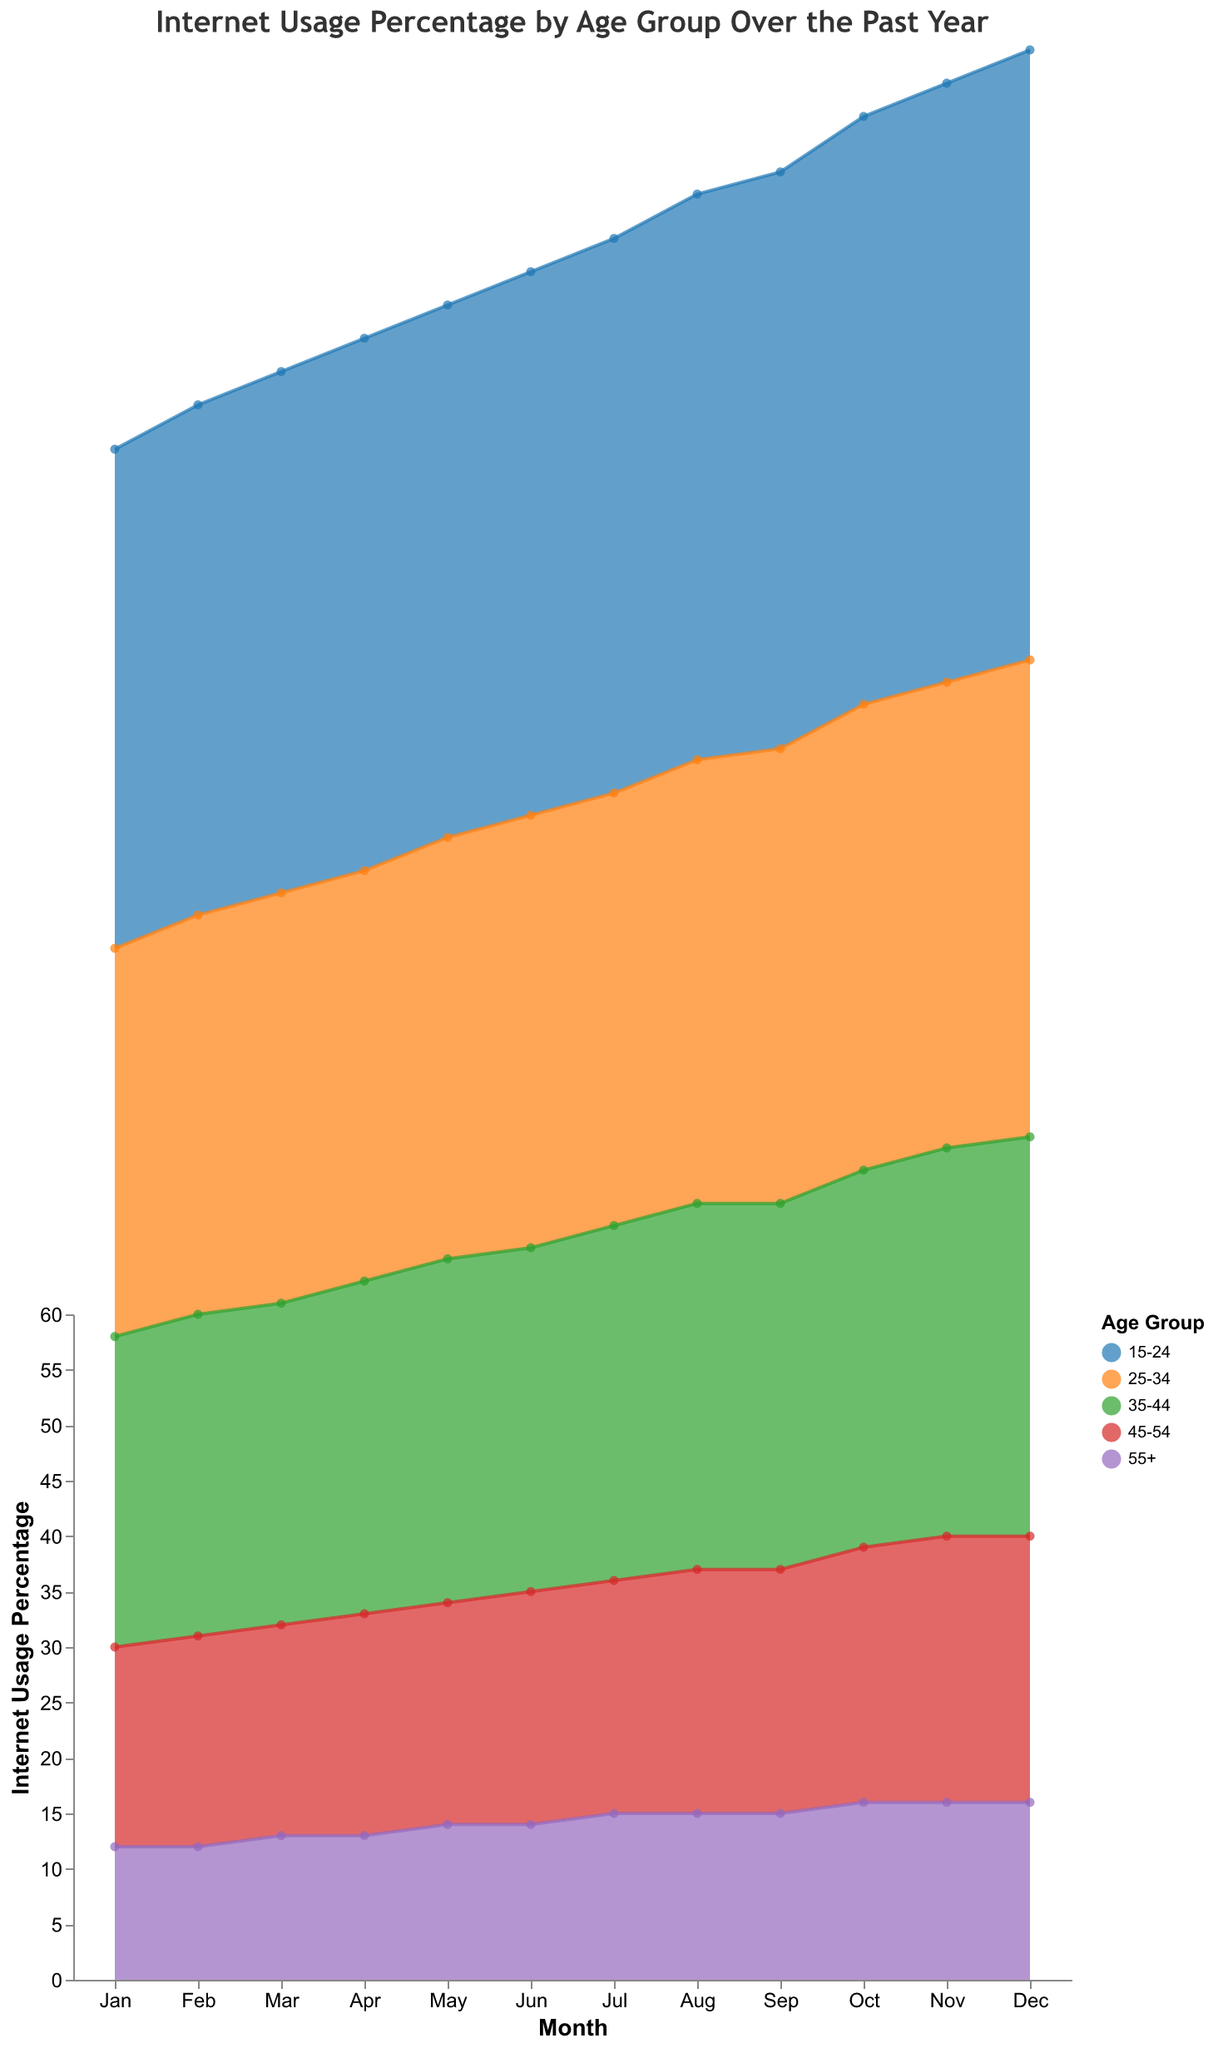What is the title of the chart? The title of the chart is located at the top of the figure and describes what the figure is about.
Answer: Internet Usage Percentage by Age Group Over the Past Year Which age group had the highest internet usage percentage in December? To find this, look at the data points for all age groups in December and identify the highest percentage.
Answer: 15-24 For the age group 25-34, what was the internet usage percentage in June? Trace the line for the age group 25-34 to the point labeled June on the x-axis and read the corresponding y-axis value.
Answer: 39 How does the internet usage percentage of the age group 45-54 change from January to December? Look at the data points for the 45-54 age group at the beginning (January) and end (December) of the year on the x-axis and compare their percentages.
Answer: Increased from 18 to 24 Which month saw the biggest increase in internet usage percentage for the age group 15-24? Identify the month-to-month changes for the age group 15-24 and note where the difference between consecutive months is the greatest.
Answer: September to October What is the average internet usage percentage in December for all age groups? Add up the usage percentages for all age groups in December and divide by the number of age groups (5). For December, the percentages are 55, 43, 36, 24, and 16.
Answer: 34.8 Which age group showed the least change in internet usage percentage over the year? Compare the differences between the highest and lowest values over the year for each age group and identify the smallest difference.
Answer: 55+ What is the net increase in internet usage percentage for the age group 35-44 from January to December? Subtract the January percentage from the December percentage for the 35-44 age group.
Answer: 36 - 28 = 8 Among all age groups, which had the lowest internet usage percentage in January? Look at the data points for all age groups in January and identify the lowest percentage.
Answer: 55+ How many data points are there for the age group 35-44? Count the number of months (Jan to Dec) each with one data point. Each month has one data point per age group, yielding 12 data points for 35-44 age group.
Answer: 12 